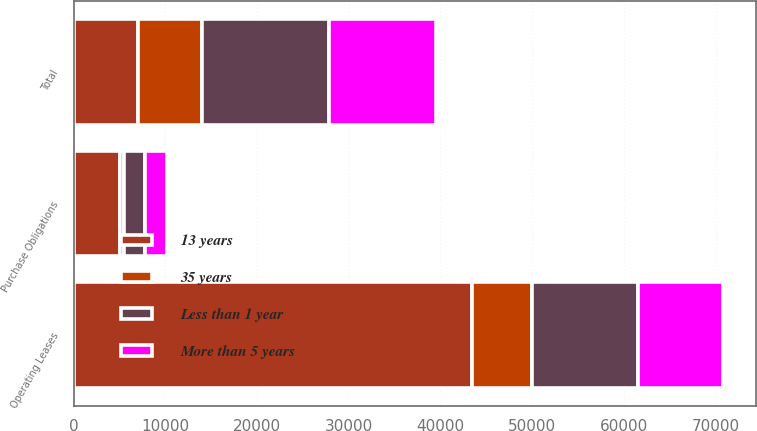<chart> <loc_0><loc_0><loc_500><loc_500><stacked_bar_chart><ecel><fcel>Operating Leases<fcel>Purchase Obligations<fcel>Total<nl><fcel>13 years<fcel>43438<fcel>5078<fcel>7003<nl><fcel>35 years<fcel>6581<fcel>422<fcel>7003<nl><fcel>Less than 1 year<fcel>11582<fcel>2251<fcel>13833<nl><fcel>More than 5 years<fcel>9263<fcel>2405<fcel>11668<nl></chart> 